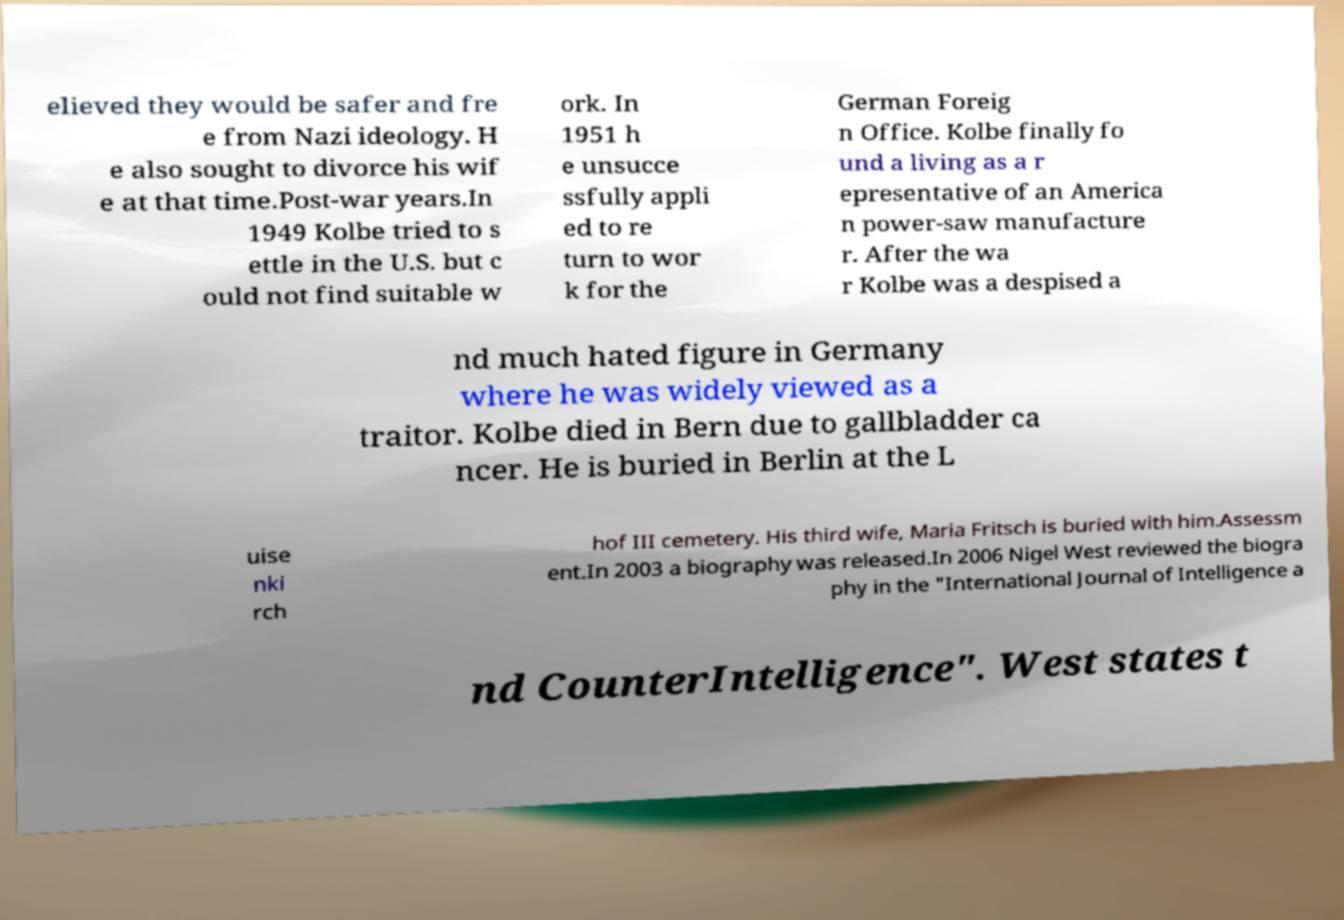Can you read and provide the text displayed in the image?This photo seems to have some interesting text. Can you extract and type it out for me? elieved they would be safer and fre e from Nazi ideology. H e also sought to divorce his wif e at that time.Post-war years.In 1949 Kolbe tried to s ettle in the U.S. but c ould not find suitable w ork. In 1951 h e unsucce ssfully appli ed to re turn to wor k for the German Foreig n Office. Kolbe finally fo und a living as a r epresentative of an America n power-saw manufacture r. After the wa r Kolbe was a despised a nd much hated figure in Germany where he was widely viewed as a traitor. Kolbe died in Bern due to gallbladder ca ncer. He is buried in Berlin at the L uise nki rch hof III cemetery. His third wife, Maria Fritsch is buried with him.Assessm ent.In 2003 a biography was released.In 2006 Nigel West reviewed the biogra phy in the "International Journal of Intelligence a nd CounterIntelligence". West states t 